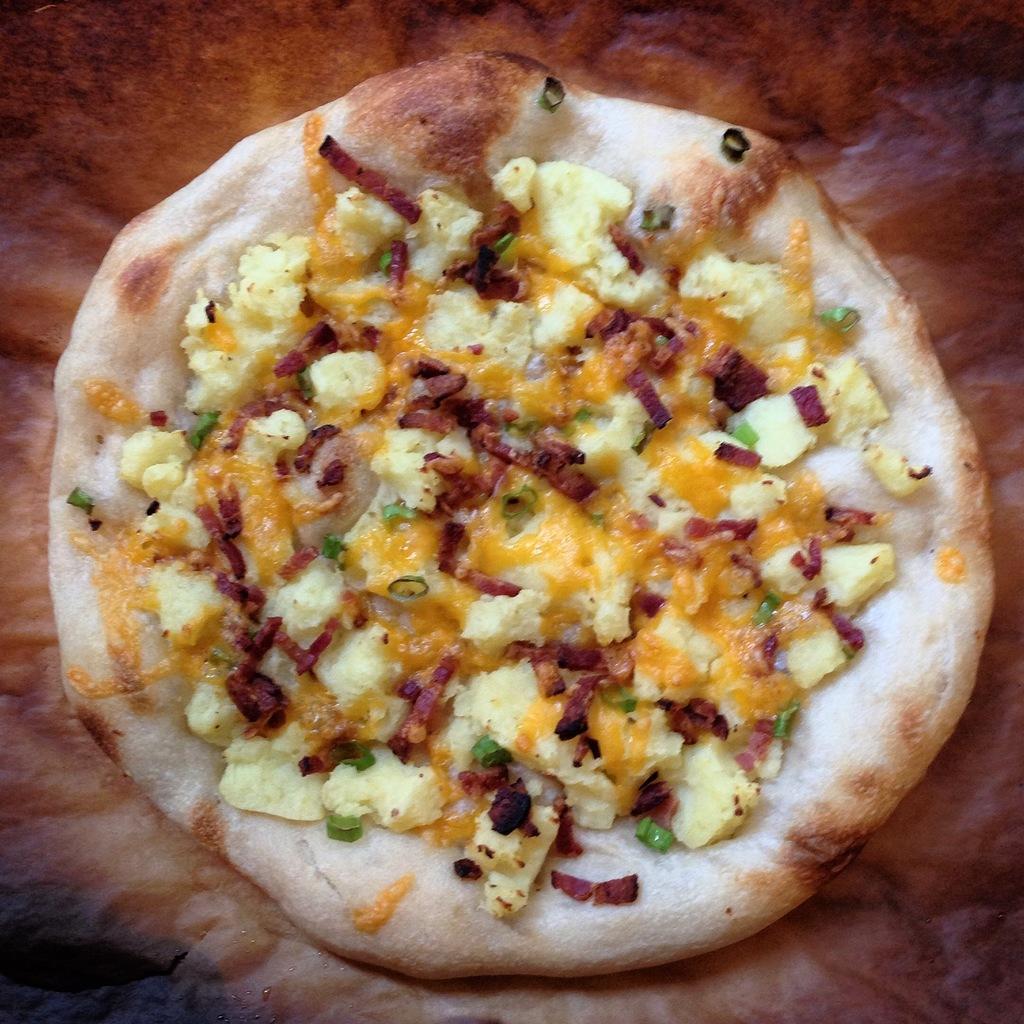Please provide a concise description of this image. In this picture we can see a pizza in the front, there is a blurry background. 